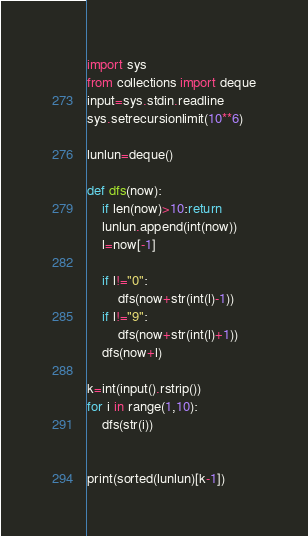<code> <loc_0><loc_0><loc_500><loc_500><_Python_>import sys
from collections import deque
input=sys.stdin.readline
sys.setrecursionlimit(10**6)

lunlun=deque()

def dfs(now):
    if len(now)>10:return
    lunlun.append(int(now))
    l=now[-1]
    
    if l!="0":
        dfs(now+str(int(l)-1))
    if l!="9":
        dfs(now+str(int(l)+1))
    dfs(now+l)

k=int(input().rstrip())
for i in range(1,10):
    dfs(str(i))


print(sorted(lunlun)[k-1])</code> 